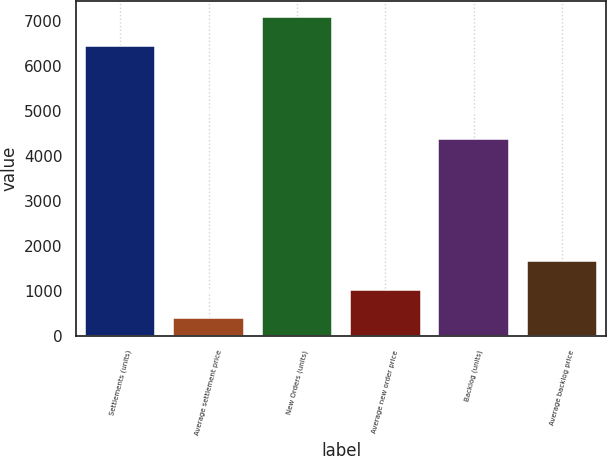Convert chart to OTSL. <chart><loc_0><loc_0><loc_500><loc_500><bar_chart><fcel>Settlements (units)<fcel>Average settlement price<fcel>New Orders (units)<fcel>Average new order price<fcel>Backlog (units)<fcel>Average backlog price<nl><fcel>6462<fcel>405.3<fcel>7091.07<fcel>1034.37<fcel>4382<fcel>1663.44<nl></chart> 